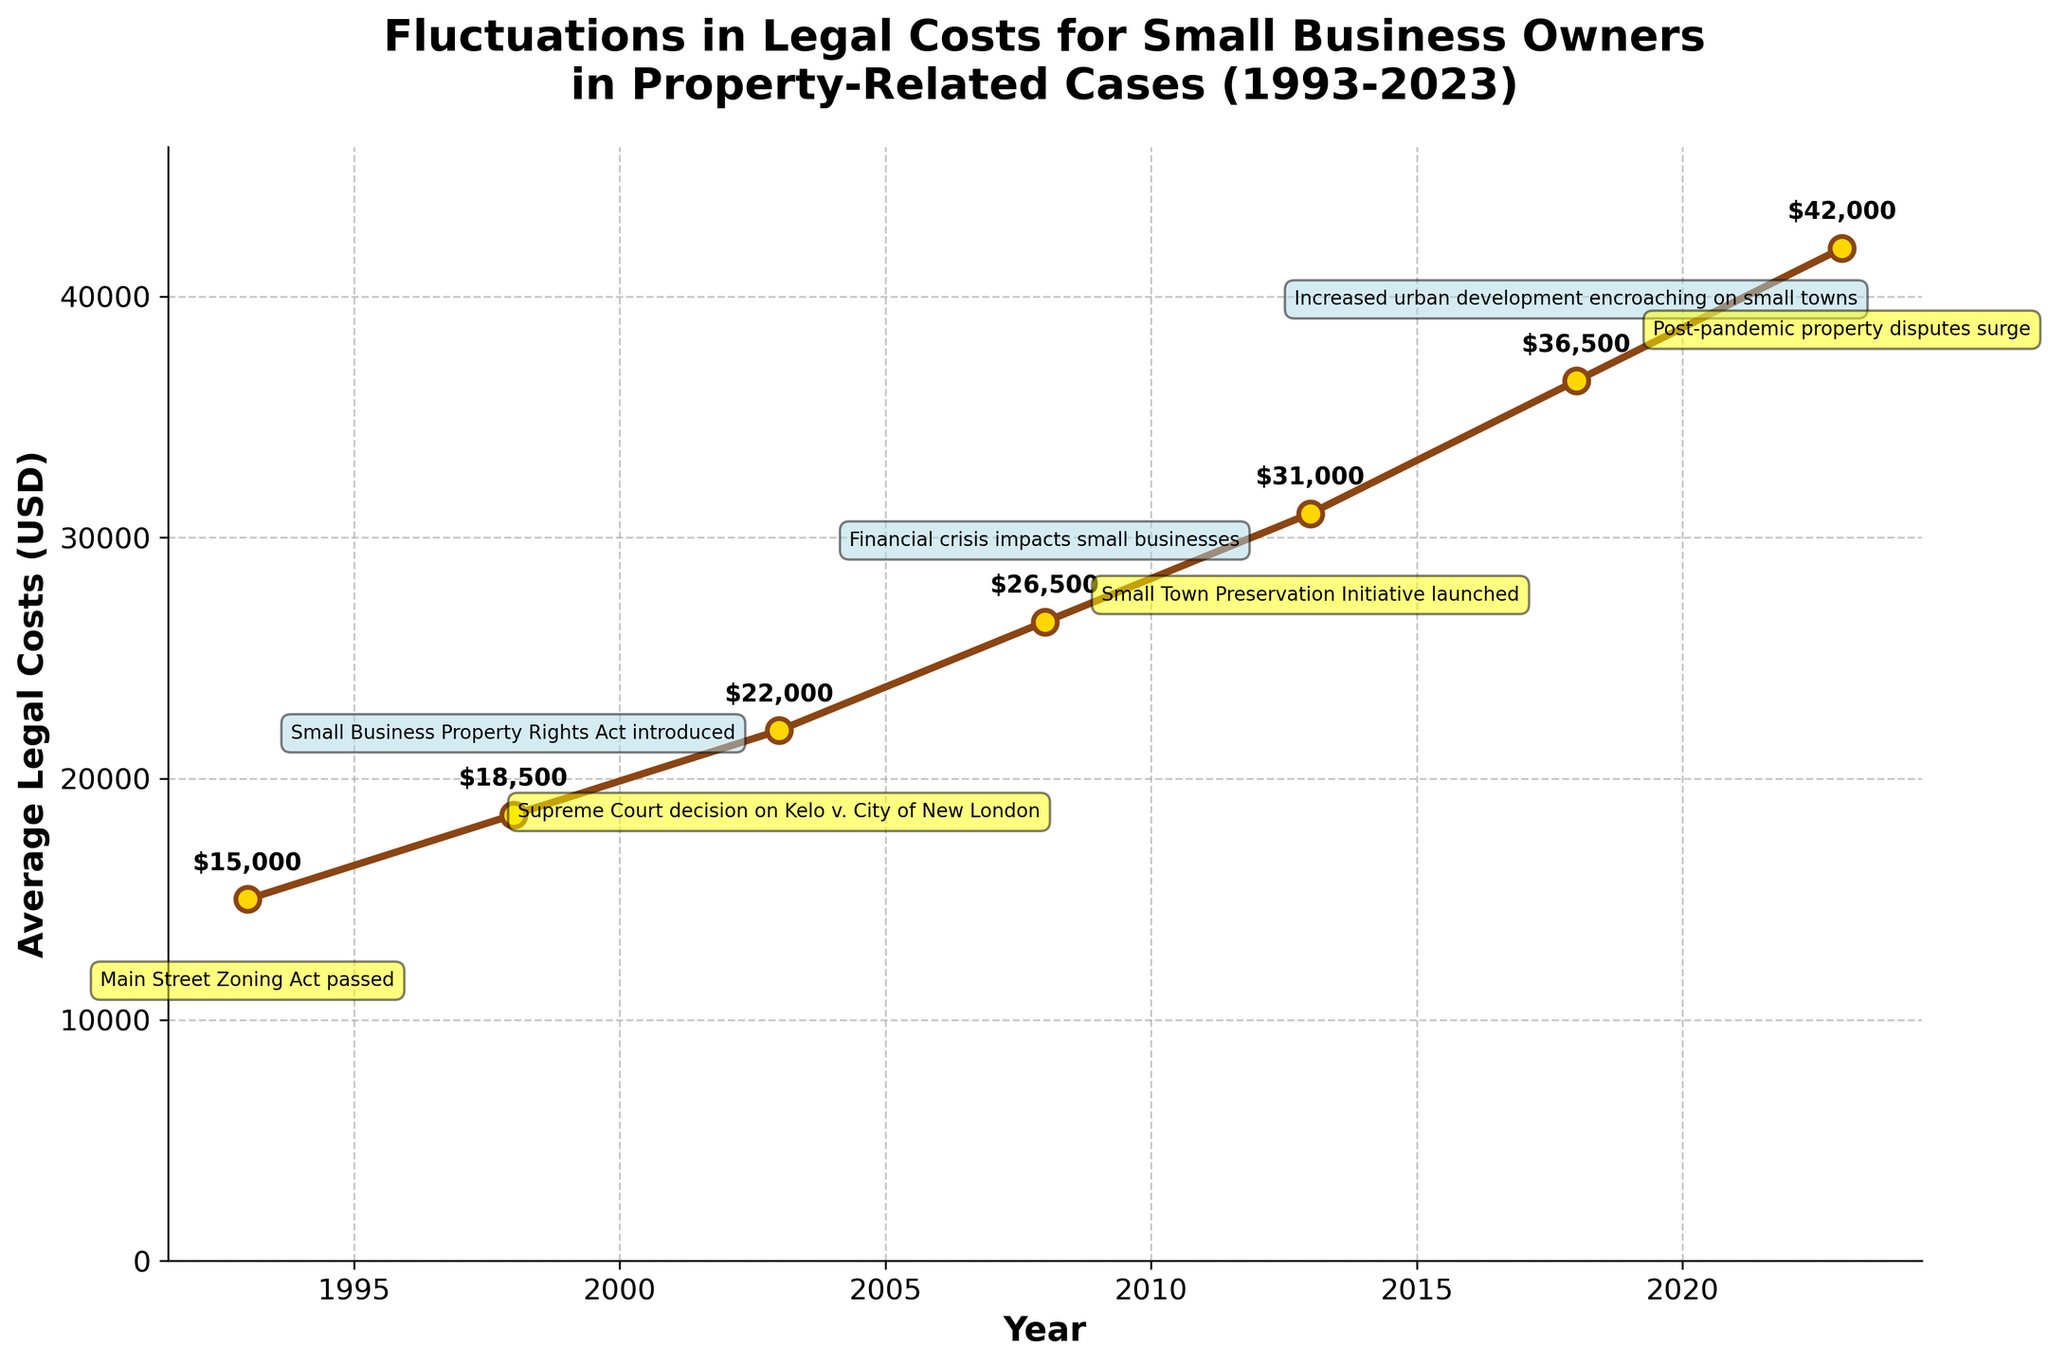What is the average legal cost in 2013? In 2013, the average legal cost is clearly marked on the y-axis where the year 2013 intersects the marked trend line. The annotated text "$31,000" also provides that information directly.
Answer: $31,000 What event occurred in 2003, and how did it affect the average legal costs? The figure indicates that in 2003, the Supreme Court decision on Kelo v. City of New London took place. The associated legal costs rose from around $18,500 in 1998 to $22,000 in 2003. This signifies an increase of $3,500.
Answer: Supreme Court decision on Kelo v. City of New London, $3,500 increase How did the average legal costs change from 2008 to 2023? The average legal costs in 2008 are $26,500, and in 2023, they are $42,000. Subtracting $26,500 from $42,000 gives an increase of $15,500.
Answer: $15,500 increase Which year saw the highest average legal costs, and what was the amount? The highest value in the dataset is the peak at the end of the timeline. According to the annotated figure, 2023 saw the highest legal costs, reaching $42,000.
Answer: 2023, $42,000 Compare the average legal costs between 1993 and 1998. Which year had higher costs, and by how much? The average legal costs in 1993 are $15,000, and in 1998, they are $18,500. The difference between the two is $18,500 - $15,000 = $3,500, indicating that 1998 had higher costs by $3,500.
Answer: 1998, $3,500 What was the impact of the 2008 financial crisis on legal costs for small businesses? The average legal costs increased from $22,000 in 2003 to $26,500 in 2008, which corresponds to a $4,500 increase. This rise can be associated with the financial crisis’s impact.
Answer: $4,500 increase What years experienced notable events that were annotated above the line, and what were the events? Examination of the annotations showing events above the line indicates that notable events in 1993 (Main Street Zoning Act passed) and 2003 (Supreme Court decision on Kelo v. City of New London) were annotated above the line.
Answer: 1993: Main Street Zoning Act passed; 2003: Supreme Court decision on Kelo v. City of New London What is the percent increase in average legal costs from 2013 to 2018? Average legal costs in 2013 were $31,000 and in 2018 were $36,500. The difference is $36,500 - $31,000 = $5,500. The percent increase is ($5,500 / $31,000) * 100% ≈ 17.74%.
Answer: Approximately 17.74% Calculate the overall percentage increase in average legal costs from 1993 to 2023. Starting from $15,000 in 1993 and reaching $42,000 in 2023, the difference is $42,000 - $15,000 = $27,000. The percentage increase is ($27,000 / $15,000) * 100% = 180%.
Answer: 180% 